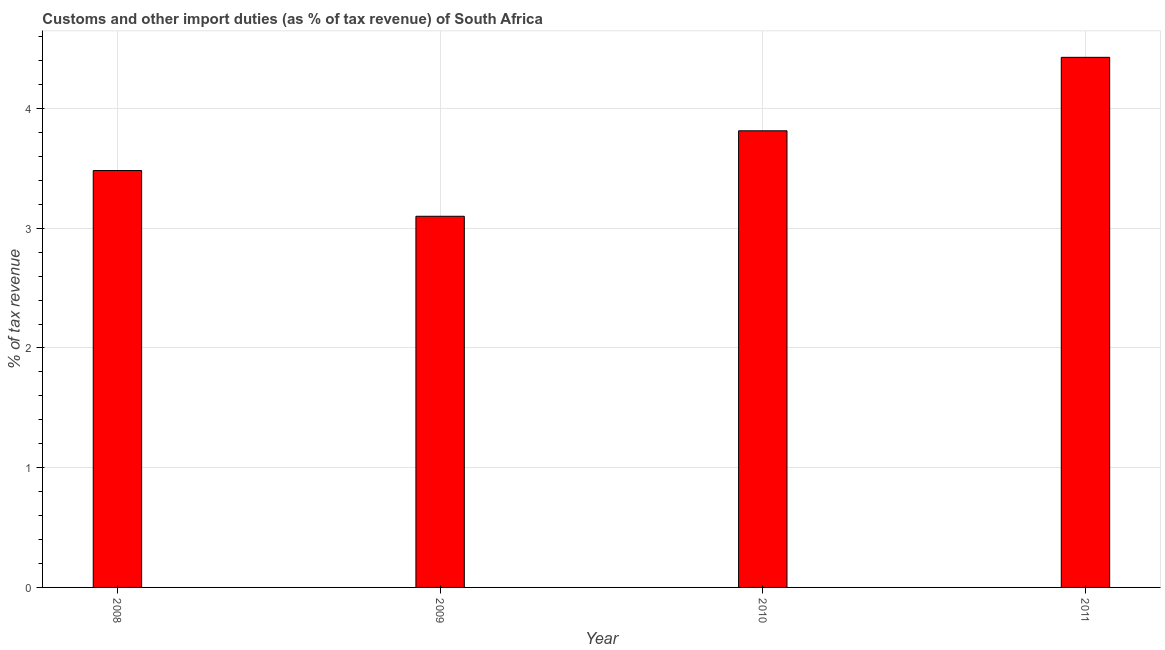Does the graph contain any zero values?
Provide a short and direct response. No. What is the title of the graph?
Offer a very short reply. Customs and other import duties (as % of tax revenue) of South Africa. What is the label or title of the X-axis?
Your answer should be compact. Year. What is the label or title of the Y-axis?
Give a very brief answer. % of tax revenue. What is the customs and other import duties in 2011?
Make the answer very short. 4.43. Across all years, what is the maximum customs and other import duties?
Keep it short and to the point. 4.43. Across all years, what is the minimum customs and other import duties?
Make the answer very short. 3.1. In which year was the customs and other import duties maximum?
Give a very brief answer. 2011. What is the sum of the customs and other import duties?
Offer a very short reply. 14.82. What is the difference between the customs and other import duties in 2010 and 2011?
Ensure brevity in your answer.  -0.61. What is the average customs and other import duties per year?
Provide a short and direct response. 3.71. What is the median customs and other import duties?
Your answer should be very brief. 3.65. What is the ratio of the customs and other import duties in 2008 to that in 2010?
Your response must be concise. 0.91. Is the customs and other import duties in 2008 less than that in 2010?
Give a very brief answer. Yes. Is the difference between the customs and other import duties in 2010 and 2011 greater than the difference between any two years?
Provide a short and direct response. No. What is the difference between the highest and the second highest customs and other import duties?
Offer a terse response. 0.61. Is the sum of the customs and other import duties in 2008 and 2011 greater than the maximum customs and other import duties across all years?
Give a very brief answer. Yes. What is the difference between the highest and the lowest customs and other import duties?
Your response must be concise. 1.33. Are all the bars in the graph horizontal?
Your response must be concise. No. How many years are there in the graph?
Provide a short and direct response. 4. What is the % of tax revenue in 2008?
Your answer should be compact. 3.48. What is the % of tax revenue of 2009?
Your response must be concise. 3.1. What is the % of tax revenue of 2010?
Your answer should be very brief. 3.81. What is the % of tax revenue in 2011?
Your response must be concise. 4.43. What is the difference between the % of tax revenue in 2008 and 2009?
Your answer should be very brief. 0.38. What is the difference between the % of tax revenue in 2008 and 2010?
Your answer should be compact. -0.33. What is the difference between the % of tax revenue in 2008 and 2011?
Make the answer very short. -0.95. What is the difference between the % of tax revenue in 2009 and 2010?
Give a very brief answer. -0.71. What is the difference between the % of tax revenue in 2009 and 2011?
Offer a terse response. -1.33. What is the difference between the % of tax revenue in 2010 and 2011?
Your response must be concise. -0.61. What is the ratio of the % of tax revenue in 2008 to that in 2009?
Offer a very short reply. 1.12. What is the ratio of the % of tax revenue in 2008 to that in 2010?
Provide a short and direct response. 0.91. What is the ratio of the % of tax revenue in 2008 to that in 2011?
Make the answer very short. 0.79. What is the ratio of the % of tax revenue in 2009 to that in 2010?
Offer a terse response. 0.81. What is the ratio of the % of tax revenue in 2009 to that in 2011?
Your response must be concise. 0.7. What is the ratio of the % of tax revenue in 2010 to that in 2011?
Keep it short and to the point. 0.86. 